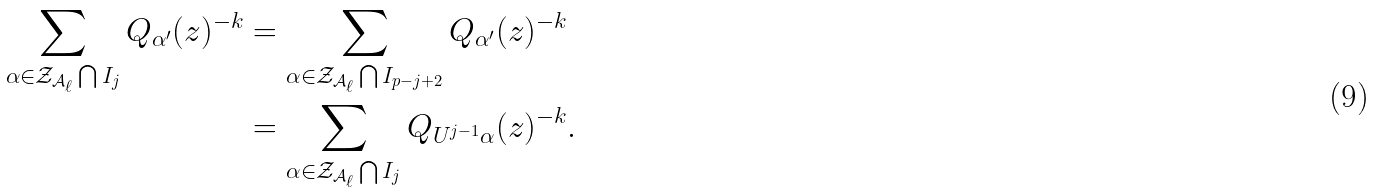<formula> <loc_0><loc_0><loc_500><loc_500>\sum _ { \alpha \in \mathcal { Z } _ { \mathcal { A } _ { \ell } } \bigcap I _ { j } } Q _ { \alpha ^ { \prime } } ( z ) ^ { - k } & = \sum _ { \alpha \in \mathcal { Z } _ { \mathcal { A } _ { \ell } } \bigcap I _ { p - j + 2 } } Q _ { \alpha ^ { \prime } } ( z ) ^ { - k } \\ & = \sum _ { \alpha \in \mathcal { Z } _ { \mathcal { A } _ { \ell } } \bigcap I _ { j } } Q _ { U ^ { j - 1 } \alpha } ( z ) ^ { - k } .</formula> 